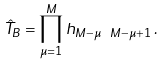Convert formula to latex. <formula><loc_0><loc_0><loc_500><loc_500>\hat { T } _ { B } = \prod _ { \mu = 1 } ^ { M } h _ { M - \mu \ M - \mu + 1 } \, .</formula> 